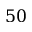<formula> <loc_0><loc_0><loc_500><loc_500>5 0</formula> 